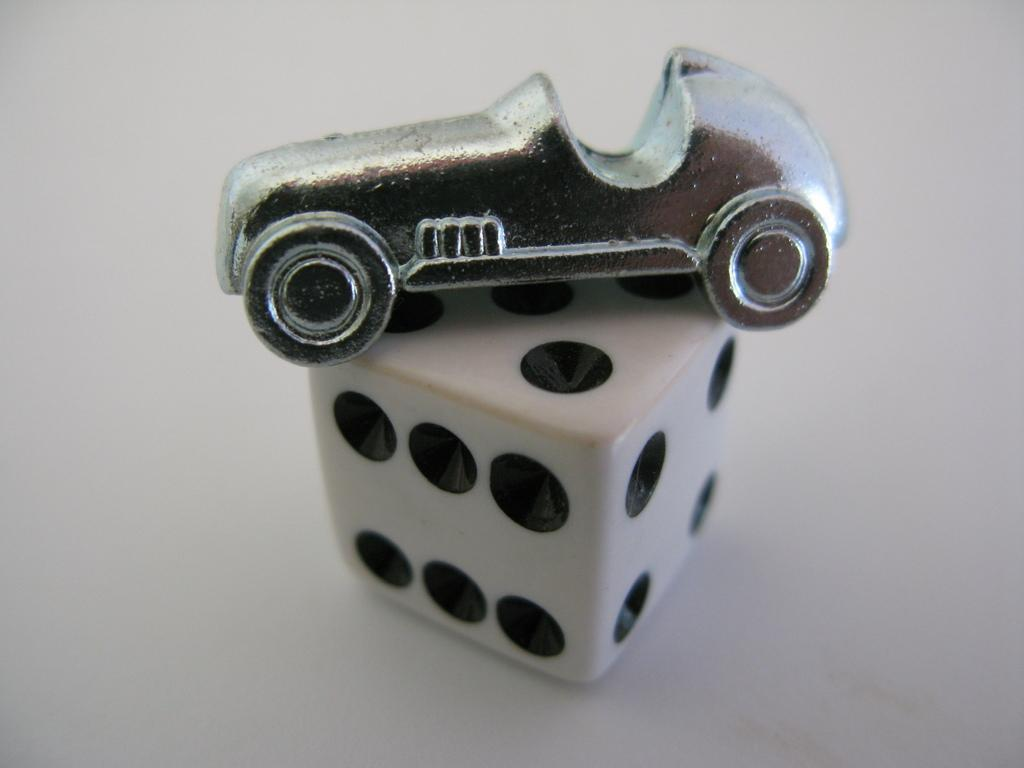What is the main object in the image? There is a dice in the image. What other object can be seen in the image? There is a toy car in the image. What color is the background of the image? The background of the image appears to be white in color. What type of pancake is being served for dinner in the image? There is no pancake or dinner scene present in the image; it features a dice and a toy car against a white background. 